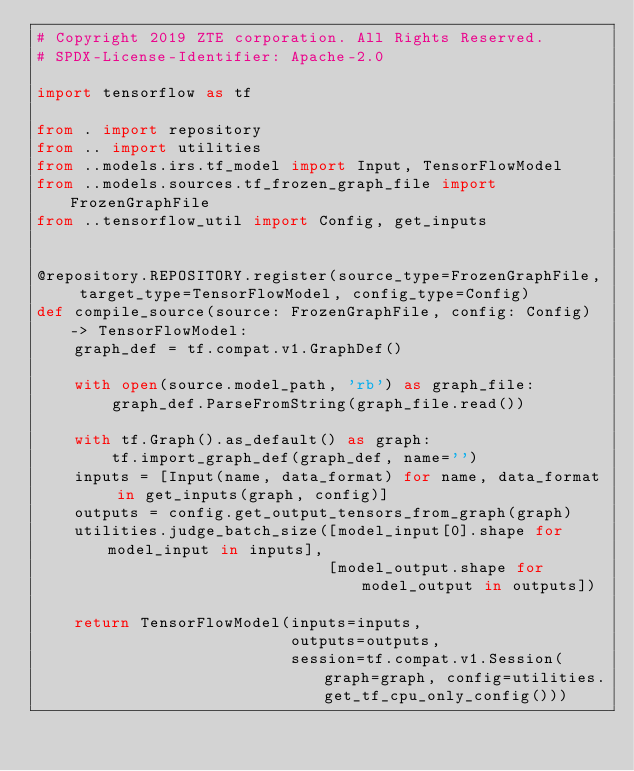Convert code to text. <code><loc_0><loc_0><loc_500><loc_500><_Python_># Copyright 2019 ZTE corporation. All Rights Reserved.
# SPDX-License-Identifier: Apache-2.0

import tensorflow as tf

from . import repository
from .. import utilities
from ..models.irs.tf_model import Input, TensorFlowModel
from ..models.sources.tf_frozen_graph_file import FrozenGraphFile
from ..tensorflow_util import Config, get_inputs


@repository.REPOSITORY.register(source_type=FrozenGraphFile, target_type=TensorFlowModel, config_type=Config)
def compile_source(source: FrozenGraphFile, config: Config) -> TensorFlowModel:
    graph_def = tf.compat.v1.GraphDef()

    with open(source.model_path, 'rb') as graph_file:
        graph_def.ParseFromString(graph_file.read())

    with tf.Graph().as_default() as graph:
        tf.import_graph_def(graph_def, name='')
    inputs = [Input(name, data_format) for name, data_format in get_inputs(graph, config)]
    outputs = config.get_output_tensors_from_graph(graph)
    utilities.judge_batch_size([model_input[0].shape for model_input in inputs],
                               [model_output.shape for model_output in outputs])

    return TensorFlowModel(inputs=inputs,
                           outputs=outputs,
                           session=tf.compat.v1.Session(graph=graph, config=utilities.get_tf_cpu_only_config()))
</code> 